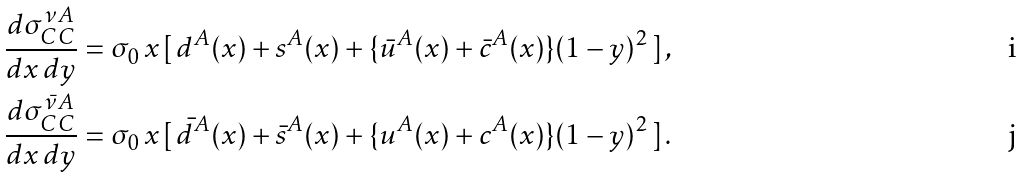Convert formula to latex. <formula><loc_0><loc_0><loc_500><loc_500>\frac { d \sigma _ { C C } ^ { \nu A } } { d x \, d y } = \sigma _ { 0 } \, x \, & [ \, d ^ { A } ( x ) + s ^ { A } ( x ) + \{ \bar { u } ^ { A } ( x ) + \bar { c } ^ { A } ( x ) \} ( 1 - y ) ^ { 2 } \, ] \, , \\ \frac { d \sigma _ { C C } ^ { \bar { \nu } A } } { d x \, d y } = \sigma _ { 0 } \, x \, & [ \, \bar { d } ^ { A } ( x ) + \bar { s } ^ { A } ( x ) + \{ u ^ { A } ( x ) + c ^ { A } ( x ) \} ( 1 - y ) ^ { 2 } \, ] \, .</formula> 